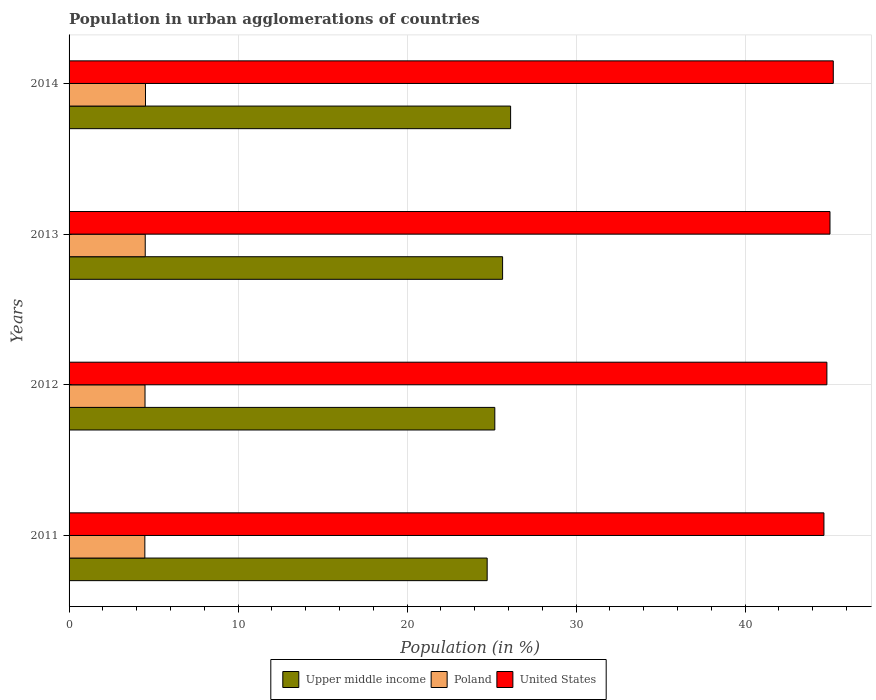Are the number of bars on each tick of the Y-axis equal?
Offer a terse response. Yes. How many bars are there on the 3rd tick from the top?
Ensure brevity in your answer.  3. What is the percentage of population in urban agglomerations in United States in 2013?
Provide a succinct answer. 45.03. Across all years, what is the maximum percentage of population in urban agglomerations in United States?
Your answer should be very brief. 45.22. Across all years, what is the minimum percentage of population in urban agglomerations in Poland?
Make the answer very short. 4.48. In which year was the percentage of population in urban agglomerations in Upper middle income maximum?
Make the answer very short. 2014. What is the total percentage of population in urban agglomerations in Poland in the graph?
Your response must be concise. 18.01. What is the difference between the percentage of population in urban agglomerations in Upper middle income in 2011 and that in 2014?
Offer a terse response. -1.39. What is the difference between the percentage of population in urban agglomerations in Upper middle income in 2011 and the percentage of population in urban agglomerations in Poland in 2012?
Offer a very short reply. 20.25. What is the average percentage of population in urban agglomerations in Poland per year?
Your answer should be compact. 4.5. In the year 2011, what is the difference between the percentage of population in urban agglomerations in Upper middle income and percentage of population in urban agglomerations in Poland?
Offer a terse response. 20.26. In how many years, is the percentage of population in urban agglomerations in United States greater than 16 %?
Ensure brevity in your answer.  4. What is the ratio of the percentage of population in urban agglomerations in Upper middle income in 2011 to that in 2012?
Your response must be concise. 0.98. Is the percentage of population in urban agglomerations in Upper middle income in 2013 less than that in 2014?
Ensure brevity in your answer.  Yes. Is the difference between the percentage of population in urban agglomerations in Upper middle income in 2011 and 2014 greater than the difference between the percentage of population in urban agglomerations in Poland in 2011 and 2014?
Your response must be concise. No. What is the difference between the highest and the second highest percentage of population in urban agglomerations in Upper middle income?
Offer a very short reply. 0.47. What is the difference between the highest and the lowest percentage of population in urban agglomerations in United States?
Provide a short and direct response. 0.55. What does the 3rd bar from the top in 2012 represents?
Give a very brief answer. Upper middle income. What does the 3rd bar from the bottom in 2012 represents?
Your answer should be very brief. United States. Is it the case that in every year, the sum of the percentage of population in urban agglomerations in Poland and percentage of population in urban agglomerations in United States is greater than the percentage of population in urban agglomerations in Upper middle income?
Offer a terse response. Yes. How many bars are there?
Keep it short and to the point. 12. How many years are there in the graph?
Your response must be concise. 4. Are the values on the major ticks of X-axis written in scientific E-notation?
Your answer should be very brief. No. Does the graph contain grids?
Give a very brief answer. Yes. How many legend labels are there?
Your answer should be compact. 3. What is the title of the graph?
Give a very brief answer. Population in urban agglomerations of countries. What is the label or title of the Y-axis?
Your answer should be compact. Years. What is the Population (in %) of Upper middle income in 2011?
Your answer should be compact. 24.74. What is the Population (in %) of Poland in 2011?
Make the answer very short. 4.48. What is the Population (in %) of United States in 2011?
Make the answer very short. 44.67. What is the Population (in %) of Upper middle income in 2012?
Your response must be concise. 25.19. What is the Population (in %) of Poland in 2012?
Make the answer very short. 4.49. What is the Population (in %) of United States in 2012?
Ensure brevity in your answer.  44.84. What is the Population (in %) in Upper middle income in 2013?
Your answer should be compact. 25.65. What is the Population (in %) in Poland in 2013?
Make the answer very short. 4.51. What is the Population (in %) of United States in 2013?
Ensure brevity in your answer.  45.03. What is the Population (in %) in Upper middle income in 2014?
Your answer should be very brief. 26.13. What is the Population (in %) of Poland in 2014?
Provide a succinct answer. 4.52. What is the Population (in %) in United States in 2014?
Give a very brief answer. 45.22. Across all years, what is the maximum Population (in %) in Upper middle income?
Your answer should be compact. 26.13. Across all years, what is the maximum Population (in %) in Poland?
Provide a succinct answer. 4.52. Across all years, what is the maximum Population (in %) in United States?
Provide a succinct answer. 45.22. Across all years, what is the minimum Population (in %) of Upper middle income?
Offer a very short reply. 24.74. Across all years, what is the minimum Population (in %) of Poland?
Your response must be concise. 4.48. Across all years, what is the minimum Population (in %) in United States?
Make the answer very short. 44.67. What is the total Population (in %) in Upper middle income in the graph?
Your response must be concise. 101.72. What is the total Population (in %) in Poland in the graph?
Give a very brief answer. 18.01. What is the total Population (in %) of United States in the graph?
Keep it short and to the point. 179.76. What is the difference between the Population (in %) in Upper middle income in 2011 and that in 2012?
Provide a short and direct response. -0.45. What is the difference between the Population (in %) of Poland in 2011 and that in 2012?
Your response must be concise. -0.01. What is the difference between the Population (in %) in United States in 2011 and that in 2012?
Your answer should be compact. -0.17. What is the difference between the Population (in %) of Upper middle income in 2011 and that in 2013?
Give a very brief answer. -0.91. What is the difference between the Population (in %) in Poland in 2011 and that in 2013?
Provide a short and direct response. -0.02. What is the difference between the Population (in %) in United States in 2011 and that in 2013?
Provide a short and direct response. -0.36. What is the difference between the Population (in %) of Upper middle income in 2011 and that in 2014?
Keep it short and to the point. -1.39. What is the difference between the Population (in %) of Poland in 2011 and that in 2014?
Provide a short and direct response. -0.04. What is the difference between the Population (in %) in United States in 2011 and that in 2014?
Offer a terse response. -0.55. What is the difference between the Population (in %) in Upper middle income in 2012 and that in 2013?
Make the answer very short. -0.46. What is the difference between the Population (in %) of Poland in 2012 and that in 2013?
Your answer should be very brief. -0.01. What is the difference between the Population (in %) in United States in 2012 and that in 2013?
Make the answer very short. -0.18. What is the difference between the Population (in %) in Upper middle income in 2012 and that in 2014?
Make the answer very short. -0.94. What is the difference between the Population (in %) in Poland in 2012 and that in 2014?
Your response must be concise. -0.03. What is the difference between the Population (in %) in United States in 2012 and that in 2014?
Your answer should be compact. -0.38. What is the difference between the Population (in %) in Upper middle income in 2013 and that in 2014?
Make the answer very short. -0.47. What is the difference between the Population (in %) of Poland in 2013 and that in 2014?
Your answer should be compact. -0.02. What is the difference between the Population (in %) of United States in 2013 and that in 2014?
Ensure brevity in your answer.  -0.2. What is the difference between the Population (in %) of Upper middle income in 2011 and the Population (in %) of Poland in 2012?
Ensure brevity in your answer.  20.25. What is the difference between the Population (in %) of Upper middle income in 2011 and the Population (in %) of United States in 2012?
Provide a short and direct response. -20.1. What is the difference between the Population (in %) in Poland in 2011 and the Population (in %) in United States in 2012?
Provide a short and direct response. -40.36. What is the difference between the Population (in %) of Upper middle income in 2011 and the Population (in %) of Poland in 2013?
Offer a terse response. 20.23. What is the difference between the Population (in %) of Upper middle income in 2011 and the Population (in %) of United States in 2013?
Provide a succinct answer. -20.29. What is the difference between the Population (in %) of Poland in 2011 and the Population (in %) of United States in 2013?
Offer a very short reply. -40.54. What is the difference between the Population (in %) of Upper middle income in 2011 and the Population (in %) of Poland in 2014?
Keep it short and to the point. 20.22. What is the difference between the Population (in %) in Upper middle income in 2011 and the Population (in %) in United States in 2014?
Offer a very short reply. -20.48. What is the difference between the Population (in %) of Poland in 2011 and the Population (in %) of United States in 2014?
Your response must be concise. -40.74. What is the difference between the Population (in %) in Upper middle income in 2012 and the Population (in %) in Poland in 2013?
Provide a succinct answer. 20.69. What is the difference between the Population (in %) in Upper middle income in 2012 and the Population (in %) in United States in 2013?
Keep it short and to the point. -19.83. What is the difference between the Population (in %) in Poland in 2012 and the Population (in %) in United States in 2013?
Your answer should be compact. -40.53. What is the difference between the Population (in %) of Upper middle income in 2012 and the Population (in %) of Poland in 2014?
Provide a short and direct response. 20.67. What is the difference between the Population (in %) in Upper middle income in 2012 and the Population (in %) in United States in 2014?
Give a very brief answer. -20.03. What is the difference between the Population (in %) in Poland in 2012 and the Population (in %) in United States in 2014?
Provide a short and direct response. -40.73. What is the difference between the Population (in %) of Upper middle income in 2013 and the Population (in %) of Poland in 2014?
Keep it short and to the point. 21.13. What is the difference between the Population (in %) of Upper middle income in 2013 and the Population (in %) of United States in 2014?
Give a very brief answer. -19.57. What is the difference between the Population (in %) in Poland in 2013 and the Population (in %) in United States in 2014?
Give a very brief answer. -40.72. What is the average Population (in %) of Upper middle income per year?
Your response must be concise. 25.43. What is the average Population (in %) in Poland per year?
Make the answer very short. 4.5. What is the average Population (in %) of United States per year?
Your answer should be very brief. 44.94. In the year 2011, what is the difference between the Population (in %) of Upper middle income and Population (in %) of Poland?
Make the answer very short. 20.26. In the year 2011, what is the difference between the Population (in %) of Upper middle income and Population (in %) of United States?
Ensure brevity in your answer.  -19.93. In the year 2011, what is the difference between the Population (in %) of Poland and Population (in %) of United States?
Make the answer very short. -40.18. In the year 2012, what is the difference between the Population (in %) in Upper middle income and Population (in %) in Poland?
Offer a very short reply. 20.7. In the year 2012, what is the difference between the Population (in %) of Upper middle income and Population (in %) of United States?
Ensure brevity in your answer.  -19.65. In the year 2012, what is the difference between the Population (in %) in Poland and Population (in %) in United States?
Your answer should be compact. -40.35. In the year 2013, what is the difference between the Population (in %) of Upper middle income and Population (in %) of Poland?
Your answer should be compact. 21.15. In the year 2013, what is the difference between the Population (in %) in Upper middle income and Population (in %) in United States?
Offer a terse response. -19.37. In the year 2013, what is the difference between the Population (in %) in Poland and Population (in %) in United States?
Your answer should be very brief. -40.52. In the year 2014, what is the difference between the Population (in %) of Upper middle income and Population (in %) of Poland?
Ensure brevity in your answer.  21.61. In the year 2014, what is the difference between the Population (in %) of Upper middle income and Population (in %) of United States?
Offer a very short reply. -19.09. In the year 2014, what is the difference between the Population (in %) of Poland and Population (in %) of United States?
Your response must be concise. -40.7. What is the ratio of the Population (in %) in Upper middle income in 2011 to that in 2012?
Ensure brevity in your answer.  0.98. What is the ratio of the Population (in %) of Poland in 2011 to that in 2012?
Offer a terse response. 1. What is the ratio of the Population (in %) of Upper middle income in 2011 to that in 2013?
Your answer should be very brief. 0.96. What is the ratio of the Population (in %) in Upper middle income in 2011 to that in 2014?
Ensure brevity in your answer.  0.95. What is the ratio of the Population (in %) of United States in 2012 to that in 2013?
Ensure brevity in your answer.  1. What is the ratio of the Population (in %) in Upper middle income in 2012 to that in 2014?
Your answer should be compact. 0.96. What is the ratio of the Population (in %) of United States in 2012 to that in 2014?
Ensure brevity in your answer.  0.99. What is the ratio of the Population (in %) of Upper middle income in 2013 to that in 2014?
Your answer should be compact. 0.98. What is the difference between the highest and the second highest Population (in %) of Upper middle income?
Provide a succinct answer. 0.47. What is the difference between the highest and the second highest Population (in %) in Poland?
Offer a very short reply. 0.02. What is the difference between the highest and the second highest Population (in %) of United States?
Keep it short and to the point. 0.2. What is the difference between the highest and the lowest Population (in %) of Upper middle income?
Offer a very short reply. 1.39. What is the difference between the highest and the lowest Population (in %) of Poland?
Your answer should be compact. 0.04. What is the difference between the highest and the lowest Population (in %) in United States?
Make the answer very short. 0.55. 